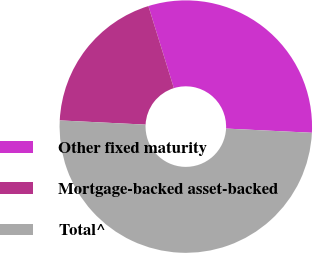Convert chart. <chart><loc_0><loc_0><loc_500><loc_500><pie_chart><fcel>Other fixed maturity<fcel>Mortgage-backed asset-backed<fcel>Total^<nl><fcel>30.57%<fcel>19.43%<fcel>50.0%<nl></chart> 